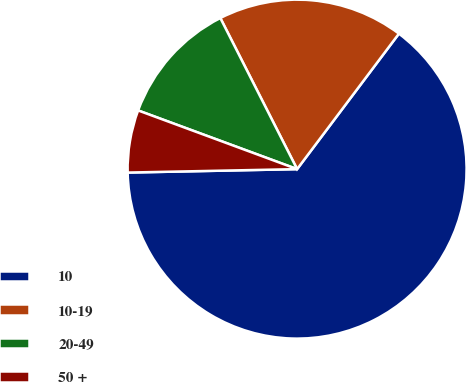Convert chart to OTSL. <chart><loc_0><loc_0><loc_500><loc_500><pie_chart><fcel>10<fcel>10-19<fcel>20-49<fcel>50 +<nl><fcel>64.42%<fcel>17.74%<fcel>11.89%<fcel>5.95%<nl></chart> 